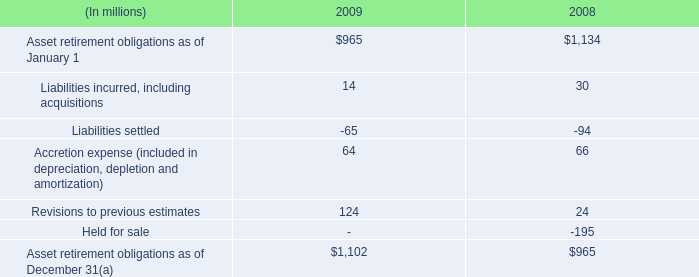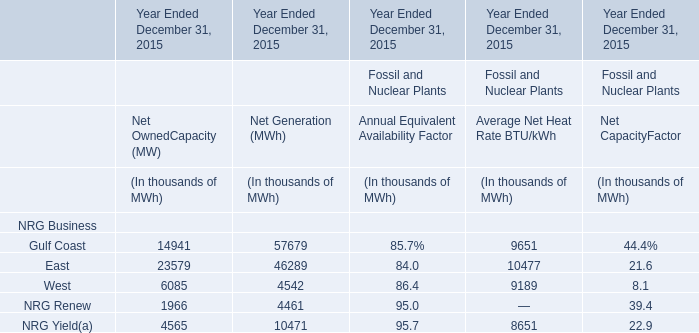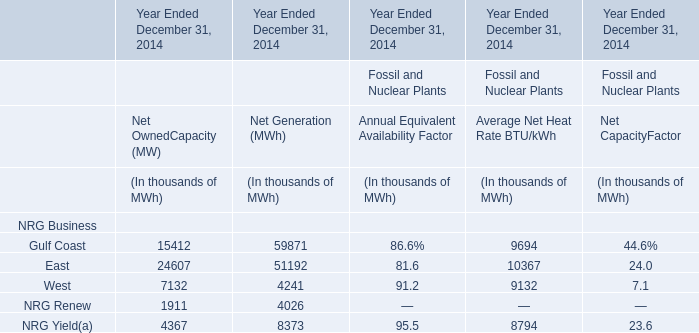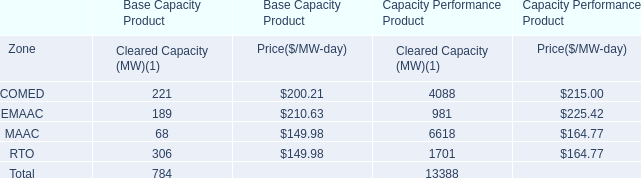What's the sum of all Average Net Heat Rate BTU/kWh that are positive in 2014? (in thousand) 
Computations: (((9694 + 10367) + 9132) + 8794)
Answer: 37987.0. 